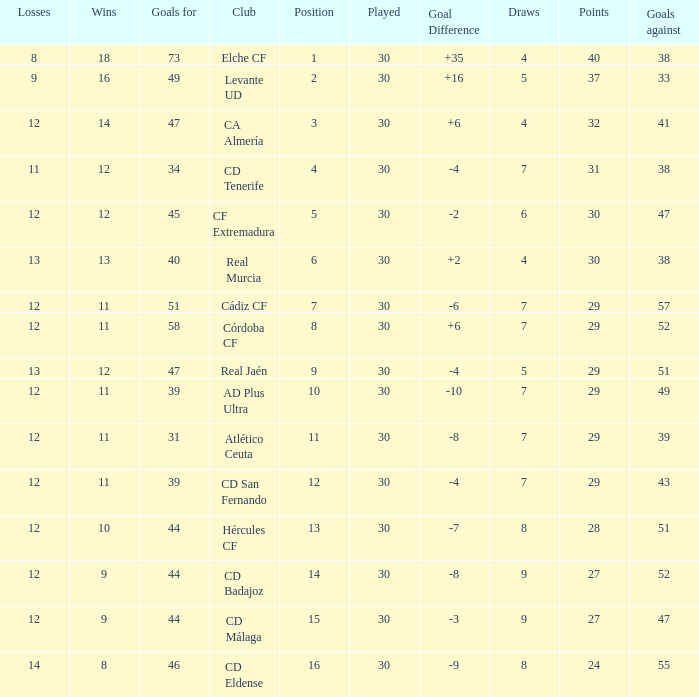What is the lowest amount of draws with less than 12 wins and less than 30 played? None. 